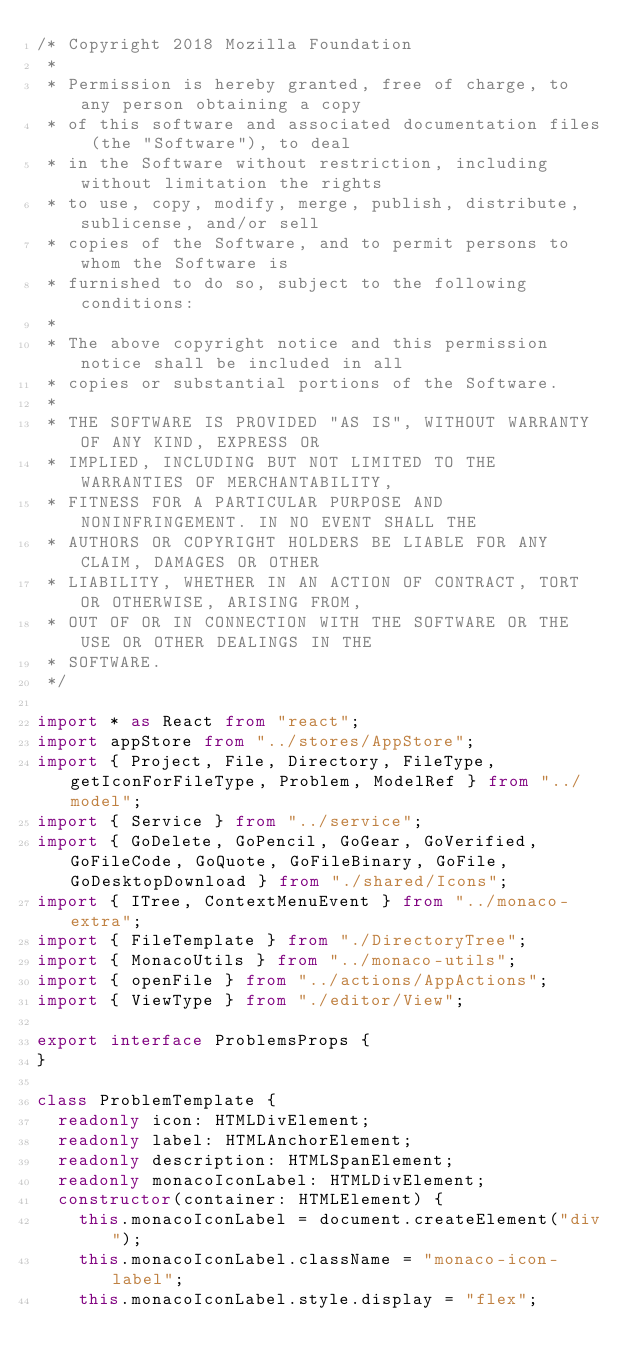<code> <loc_0><loc_0><loc_500><loc_500><_TypeScript_>/* Copyright 2018 Mozilla Foundation
 *
 * Permission is hereby granted, free of charge, to any person obtaining a copy
 * of this software and associated documentation files (the "Software"), to deal
 * in the Software without restriction, including without limitation the rights
 * to use, copy, modify, merge, publish, distribute, sublicense, and/or sell
 * copies of the Software, and to permit persons to whom the Software is
 * furnished to do so, subject to the following conditions:
 *
 * The above copyright notice and this permission notice shall be included in all
 * copies or substantial portions of the Software.
 *
 * THE SOFTWARE IS PROVIDED "AS IS", WITHOUT WARRANTY OF ANY KIND, EXPRESS OR
 * IMPLIED, INCLUDING BUT NOT LIMITED TO THE WARRANTIES OF MERCHANTABILITY,
 * FITNESS FOR A PARTICULAR PURPOSE AND NONINFRINGEMENT. IN NO EVENT SHALL THE
 * AUTHORS OR COPYRIGHT HOLDERS BE LIABLE FOR ANY CLAIM, DAMAGES OR OTHER
 * LIABILITY, WHETHER IN AN ACTION OF CONTRACT, TORT OR OTHERWISE, ARISING FROM,
 * OUT OF OR IN CONNECTION WITH THE SOFTWARE OR THE USE OR OTHER DEALINGS IN THE
 * SOFTWARE.
 */

import * as React from "react";
import appStore from "../stores/AppStore";
import { Project, File, Directory, FileType, getIconForFileType, Problem, ModelRef } from "../model";
import { Service } from "../service";
import { GoDelete, GoPencil, GoGear, GoVerified, GoFileCode, GoQuote, GoFileBinary, GoFile, GoDesktopDownload } from "./shared/Icons";
import { ITree, ContextMenuEvent } from "../monaco-extra";
import { FileTemplate } from "./DirectoryTree";
import { MonacoUtils } from "../monaco-utils";
import { openFile } from "../actions/AppActions";
import { ViewType } from "./editor/View";

export interface ProblemsProps {
}

class ProblemTemplate {
  readonly icon: HTMLDivElement;
  readonly label: HTMLAnchorElement;
  readonly description: HTMLSpanElement;
  readonly monacoIconLabel: HTMLDivElement;
  constructor(container: HTMLElement) {
    this.monacoIconLabel = document.createElement("div");
    this.monacoIconLabel.className = "monaco-icon-label";
    this.monacoIconLabel.style.display = "flex";</code> 